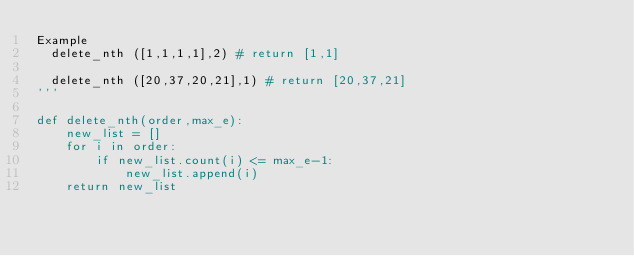Convert code to text. <code><loc_0><loc_0><loc_500><loc_500><_Python_>Example
  delete_nth ([1,1,1,1],2) # return [1,1]

  delete_nth ([20,37,20,21],1) # return [20,37,21]
'''

def delete_nth(order,max_e):
    new_list = []
    for i in order:
        if new_list.count(i) <= max_e-1:
            new_list.append(i)
    return new_list</code> 